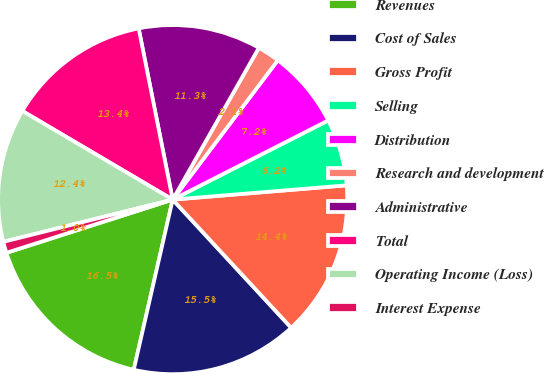Convert chart to OTSL. <chart><loc_0><loc_0><loc_500><loc_500><pie_chart><fcel>Revenues<fcel>Cost of Sales<fcel>Gross Profit<fcel>Selling<fcel>Distribution<fcel>Research and development<fcel>Administrative<fcel>Total<fcel>Operating Income (Loss)<fcel>Interest Expense<nl><fcel>16.49%<fcel>15.46%<fcel>14.43%<fcel>6.19%<fcel>7.22%<fcel>2.07%<fcel>11.34%<fcel>13.4%<fcel>12.37%<fcel>1.04%<nl></chart> 